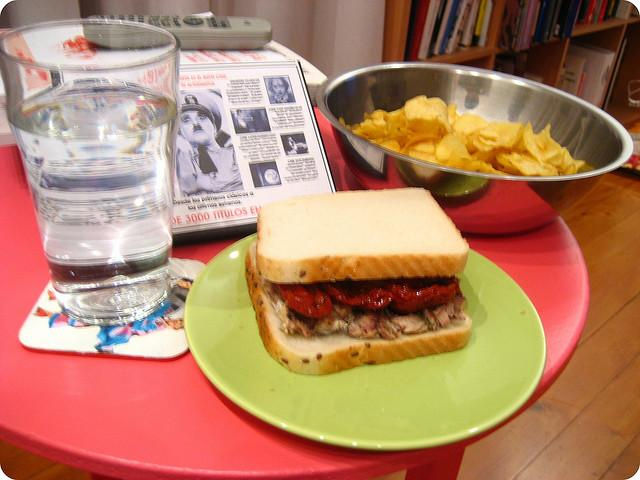What side dish is to be enjoyed with this sandwich? Please explain your reasoning. potato chips. By the texture and the fact that sandwiches usually have this side dish, you can surmise what it is. 